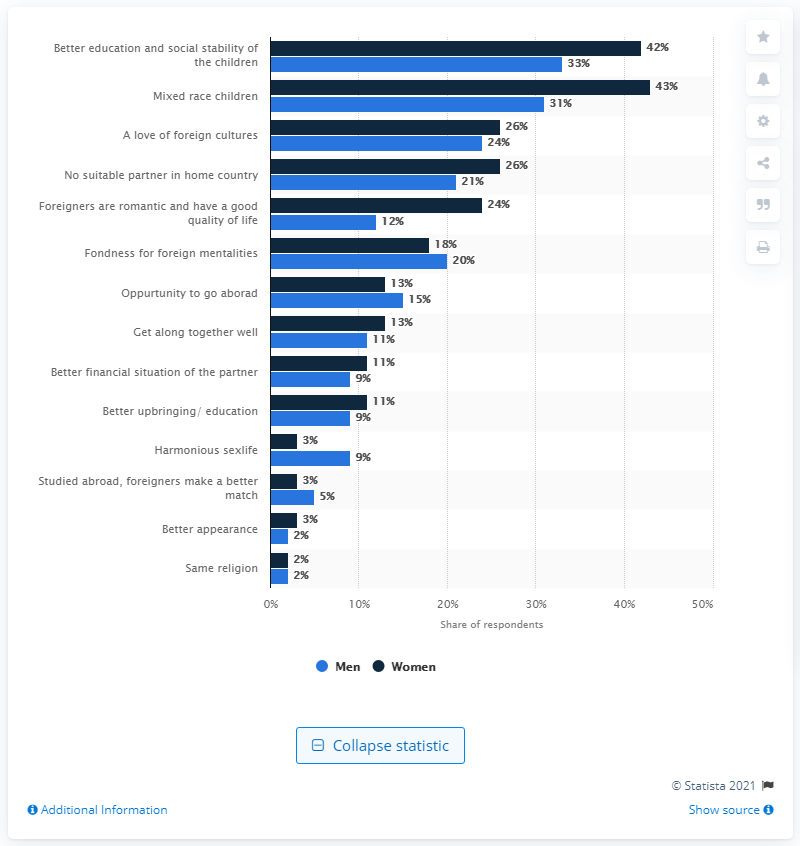Give some essential details in this illustration. According to a survey conducted in 2012, a significant percentage of men in China believed that having a better appearance was an advantage of marrying someone from outside the country. 